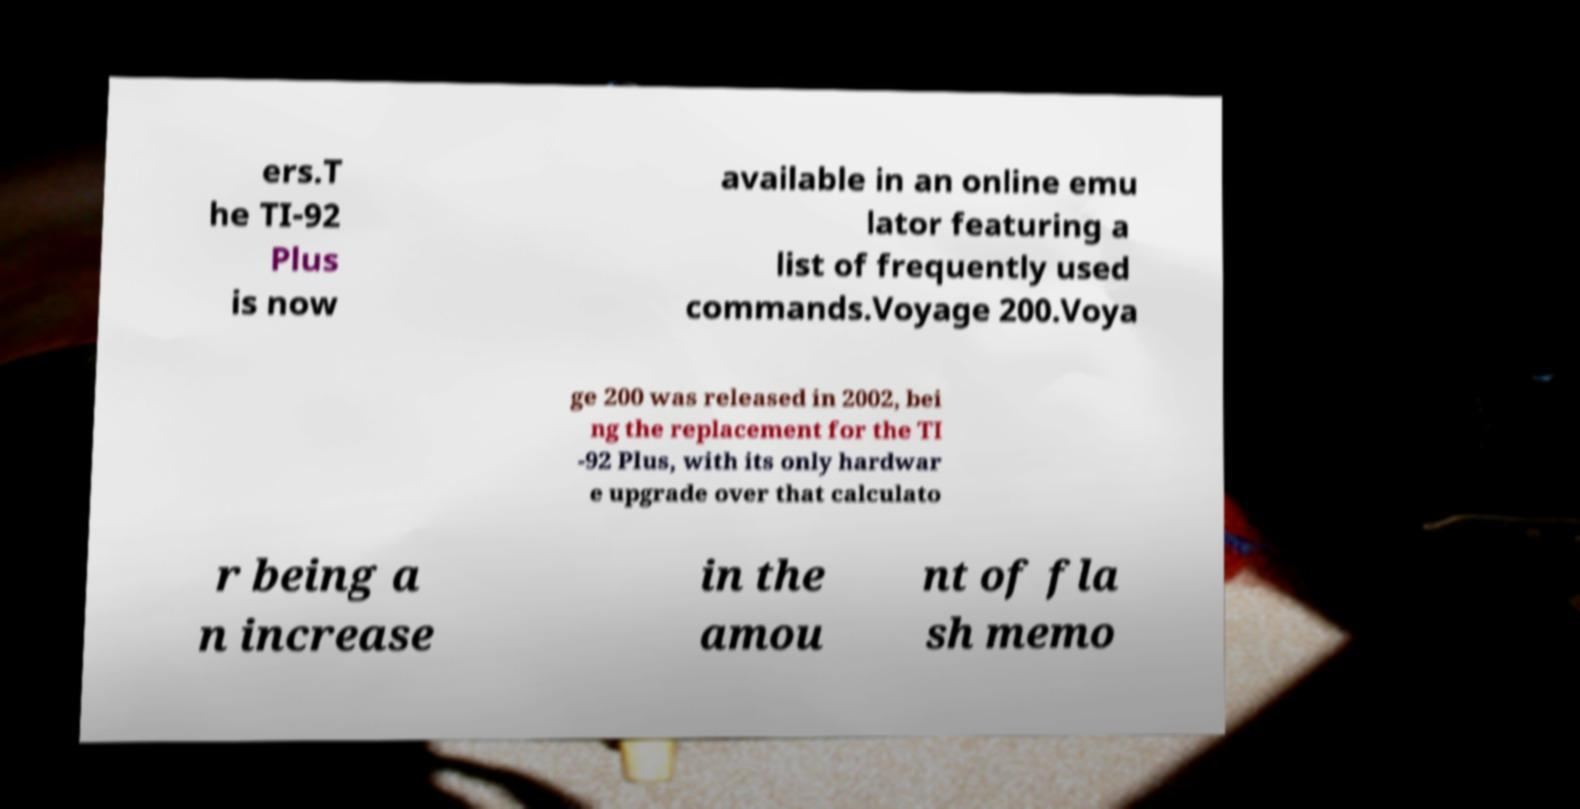I need the written content from this picture converted into text. Can you do that? ers.T he TI-92 Plus is now available in an online emu lator featuring a list of frequently used commands.Voyage 200.Voya ge 200 was released in 2002, bei ng the replacement for the TI -92 Plus, with its only hardwar e upgrade over that calculato r being a n increase in the amou nt of fla sh memo 